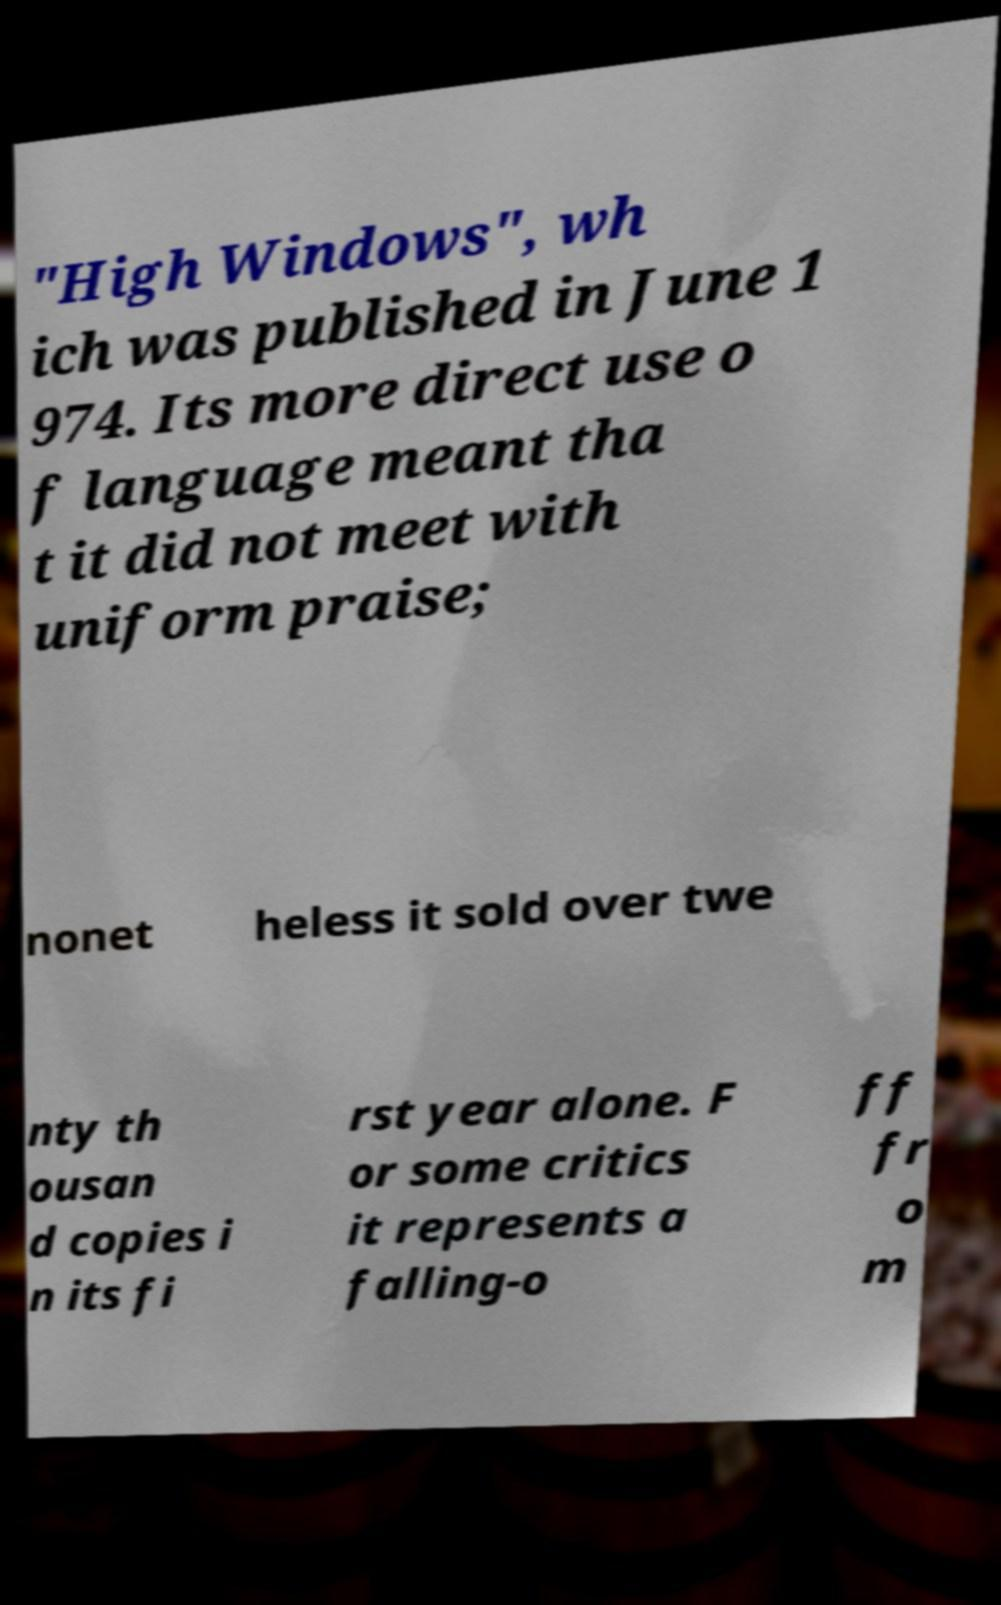For documentation purposes, I need the text within this image transcribed. Could you provide that? "High Windows", wh ich was published in June 1 974. Its more direct use o f language meant tha t it did not meet with uniform praise; nonet heless it sold over twe nty th ousan d copies i n its fi rst year alone. F or some critics it represents a falling-o ff fr o m 